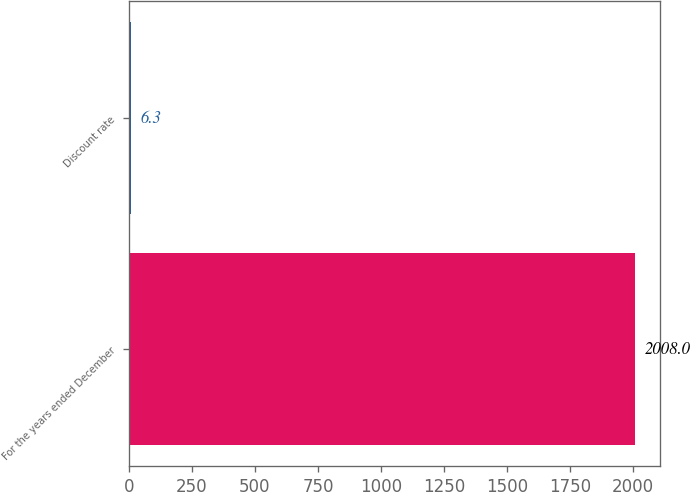Convert chart to OTSL. <chart><loc_0><loc_0><loc_500><loc_500><bar_chart><fcel>For the years ended December<fcel>Discount rate<nl><fcel>2008<fcel>6.3<nl></chart> 